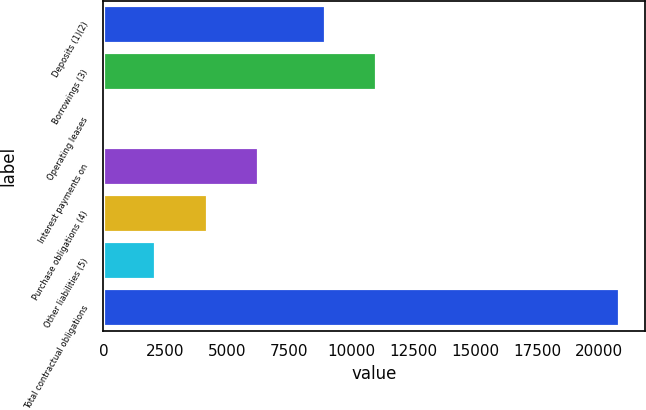<chart> <loc_0><loc_0><loc_500><loc_500><bar_chart><fcel>Deposits (1)(2)<fcel>Borrowings (3)<fcel>Operating leases<fcel>Interest payments on<fcel>Purchase obligations (4)<fcel>Other liabilities (5)<fcel>Total contractual obligations<nl><fcel>8930<fcel>11006.9<fcel>23<fcel>6253.7<fcel>4176.8<fcel>2099.9<fcel>20792<nl></chart> 